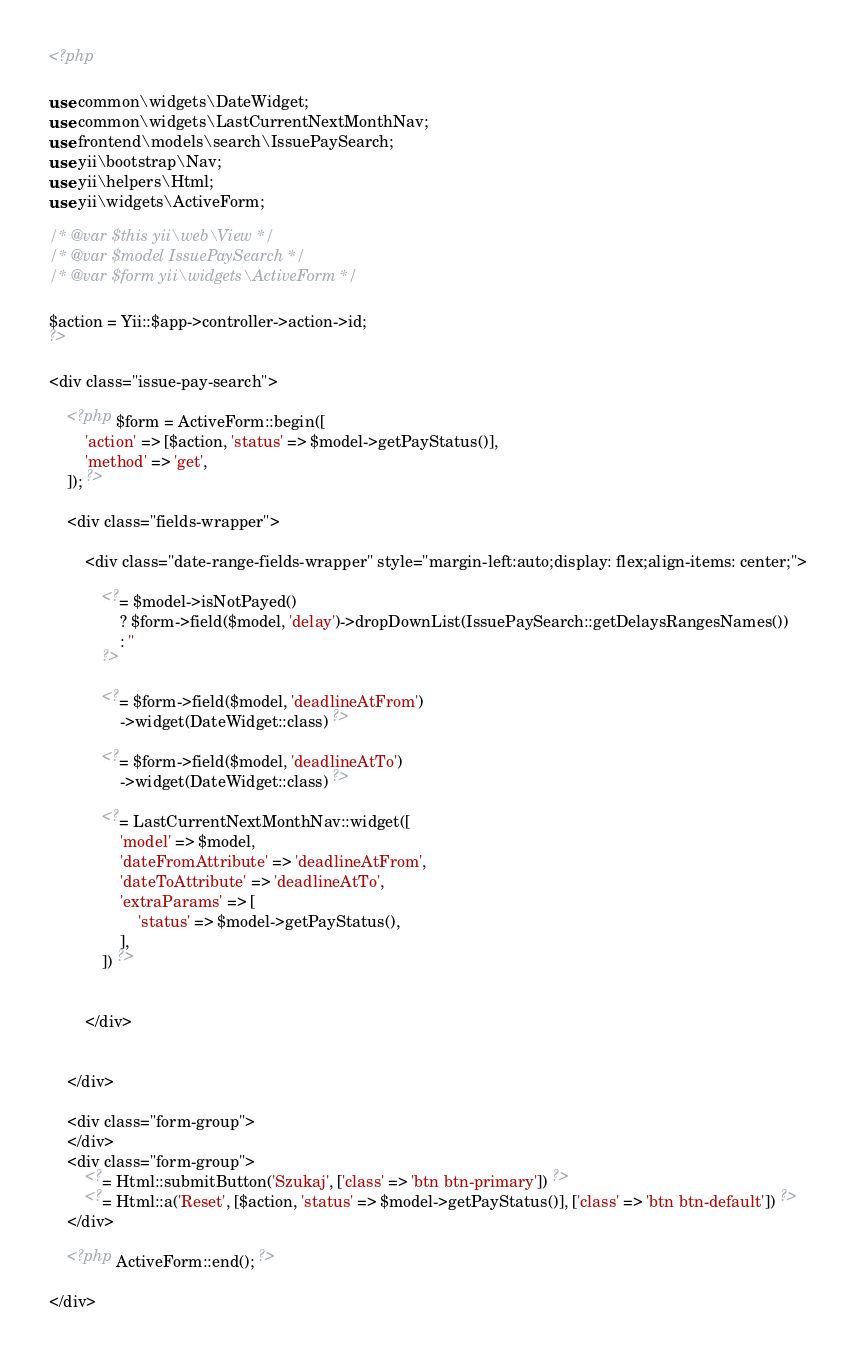<code> <loc_0><loc_0><loc_500><loc_500><_PHP_><?php

use common\widgets\DateWidget;
use common\widgets\LastCurrentNextMonthNav;
use frontend\models\search\IssuePaySearch;
use yii\bootstrap\Nav;
use yii\helpers\Html;
use yii\widgets\ActiveForm;

/* @var $this yii\web\View */
/* @var $model IssuePaySearch */
/* @var $form yii\widgets\ActiveForm */

$action = Yii::$app->controller->action->id;
?>

<div class="issue-pay-search">

	<?php $form = ActiveForm::begin([
		'action' => [$action, 'status' => $model->getPayStatus()],
		'method' => 'get',
	]); ?>

	<div class="fields-wrapper">

		<div class="date-range-fields-wrapper" style="margin-left:auto;display: flex;align-items: center;">

			<?= $model->isNotPayed()
				? $form->field($model, 'delay')->dropDownList(IssuePaySearch::getDelaysRangesNames())
				: ''
			?>

			<?= $form->field($model, 'deadlineAtFrom')
				->widget(DateWidget::class) ?>

			<?= $form->field($model, 'deadlineAtTo')
				->widget(DateWidget::class) ?>

			<?= LastCurrentNextMonthNav::widget([
				'model' => $model,
				'dateFromAttribute' => 'deadlineAtFrom',
				'dateToAttribute' => 'deadlineAtTo',
				'extraParams' => [
					'status' => $model->getPayStatus(),
				],
			]) ?>


		</div>


	</div>

	<div class="form-group">
	</div>
	<div class="form-group">
		<?= Html::submitButton('Szukaj', ['class' => 'btn btn-primary']) ?>
		<?= Html::a('Reset', [$action, 'status' => $model->getPayStatus()], ['class' => 'btn btn-default']) ?>
	</div>

	<?php ActiveForm::end(); ?>

</div>
</code> 